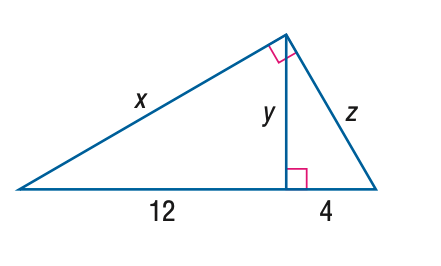Answer the mathemtical geometry problem and directly provide the correct option letter.
Question: Find x.
Choices: A: 8 B: 4 \sqrt { 6 } C: 12 D: 8 \sqrt { 3 } D 